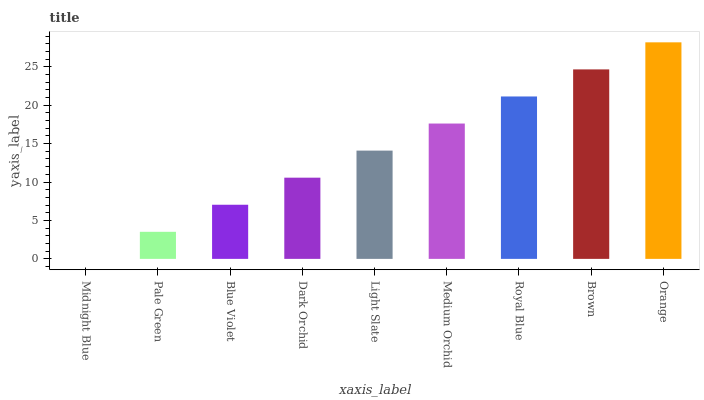Is Midnight Blue the minimum?
Answer yes or no. Yes. Is Orange the maximum?
Answer yes or no. Yes. Is Pale Green the minimum?
Answer yes or no. No. Is Pale Green the maximum?
Answer yes or no. No. Is Pale Green greater than Midnight Blue?
Answer yes or no. Yes. Is Midnight Blue less than Pale Green?
Answer yes or no. Yes. Is Midnight Blue greater than Pale Green?
Answer yes or no. No. Is Pale Green less than Midnight Blue?
Answer yes or no. No. Is Light Slate the high median?
Answer yes or no. Yes. Is Light Slate the low median?
Answer yes or no. Yes. Is Royal Blue the high median?
Answer yes or no. No. Is Blue Violet the low median?
Answer yes or no. No. 